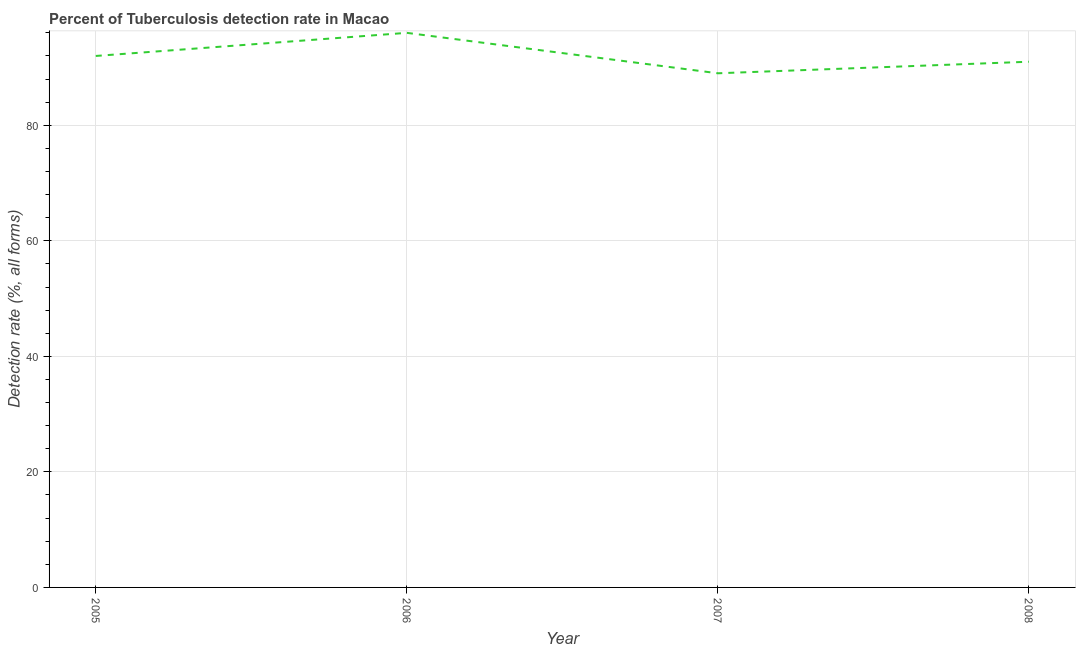What is the detection rate of tuberculosis in 2008?
Provide a succinct answer. 91. Across all years, what is the maximum detection rate of tuberculosis?
Keep it short and to the point. 96. Across all years, what is the minimum detection rate of tuberculosis?
Offer a terse response. 89. What is the sum of the detection rate of tuberculosis?
Offer a terse response. 368. What is the difference between the detection rate of tuberculosis in 2005 and 2008?
Give a very brief answer. 1. What is the average detection rate of tuberculosis per year?
Ensure brevity in your answer.  92. What is the median detection rate of tuberculosis?
Ensure brevity in your answer.  91.5. Do a majority of the years between 2005 and 2007 (inclusive) have detection rate of tuberculosis greater than 88 %?
Keep it short and to the point. Yes. What is the ratio of the detection rate of tuberculosis in 2007 to that in 2008?
Make the answer very short. 0.98. Is the difference between the detection rate of tuberculosis in 2005 and 2008 greater than the difference between any two years?
Provide a short and direct response. No. What is the difference between the highest and the second highest detection rate of tuberculosis?
Give a very brief answer. 4. What is the difference between the highest and the lowest detection rate of tuberculosis?
Make the answer very short. 7. In how many years, is the detection rate of tuberculosis greater than the average detection rate of tuberculosis taken over all years?
Keep it short and to the point. 1. Does the detection rate of tuberculosis monotonically increase over the years?
Keep it short and to the point. No. How many lines are there?
Offer a terse response. 1. How many years are there in the graph?
Give a very brief answer. 4. Does the graph contain any zero values?
Your response must be concise. No. Does the graph contain grids?
Your answer should be very brief. Yes. What is the title of the graph?
Give a very brief answer. Percent of Tuberculosis detection rate in Macao. What is the label or title of the Y-axis?
Offer a very short reply. Detection rate (%, all forms). What is the Detection rate (%, all forms) of 2005?
Offer a very short reply. 92. What is the Detection rate (%, all forms) in 2006?
Provide a succinct answer. 96. What is the Detection rate (%, all forms) of 2007?
Provide a short and direct response. 89. What is the Detection rate (%, all forms) of 2008?
Provide a succinct answer. 91. What is the difference between the Detection rate (%, all forms) in 2005 and 2006?
Offer a terse response. -4. What is the difference between the Detection rate (%, all forms) in 2005 and 2007?
Your answer should be compact. 3. What is the difference between the Detection rate (%, all forms) in 2005 and 2008?
Ensure brevity in your answer.  1. What is the ratio of the Detection rate (%, all forms) in 2005 to that in 2006?
Provide a short and direct response. 0.96. What is the ratio of the Detection rate (%, all forms) in 2005 to that in 2007?
Ensure brevity in your answer.  1.03. What is the ratio of the Detection rate (%, all forms) in 2005 to that in 2008?
Make the answer very short. 1.01. What is the ratio of the Detection rate (%, all forms) in 2006 to that in 2007?
Make the answer very short. 1.08. What is the ratio of the Detection rate (%, all forms) in 2006 to that in 2008?
Your answer should be very brief. 1.05. What is the ratio of the Detection rate (%, all forms) in 2007 to that in 2008?
Ensure brevity in your answer.  0.98. 